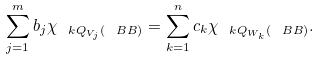<formula> <loc_0><loc_0><loc_500><loc_500>\sum _ { j = 1 } ^ { m } b _ { j } \chi _ { \ k Q _ { V _ { j } } ( \ B B ) } = \sum _ { k = 1 } ^ { n } c _ { k } \chi _ { \ k Q _ { W _ { k } } ( \ B B ) } .</formula> 